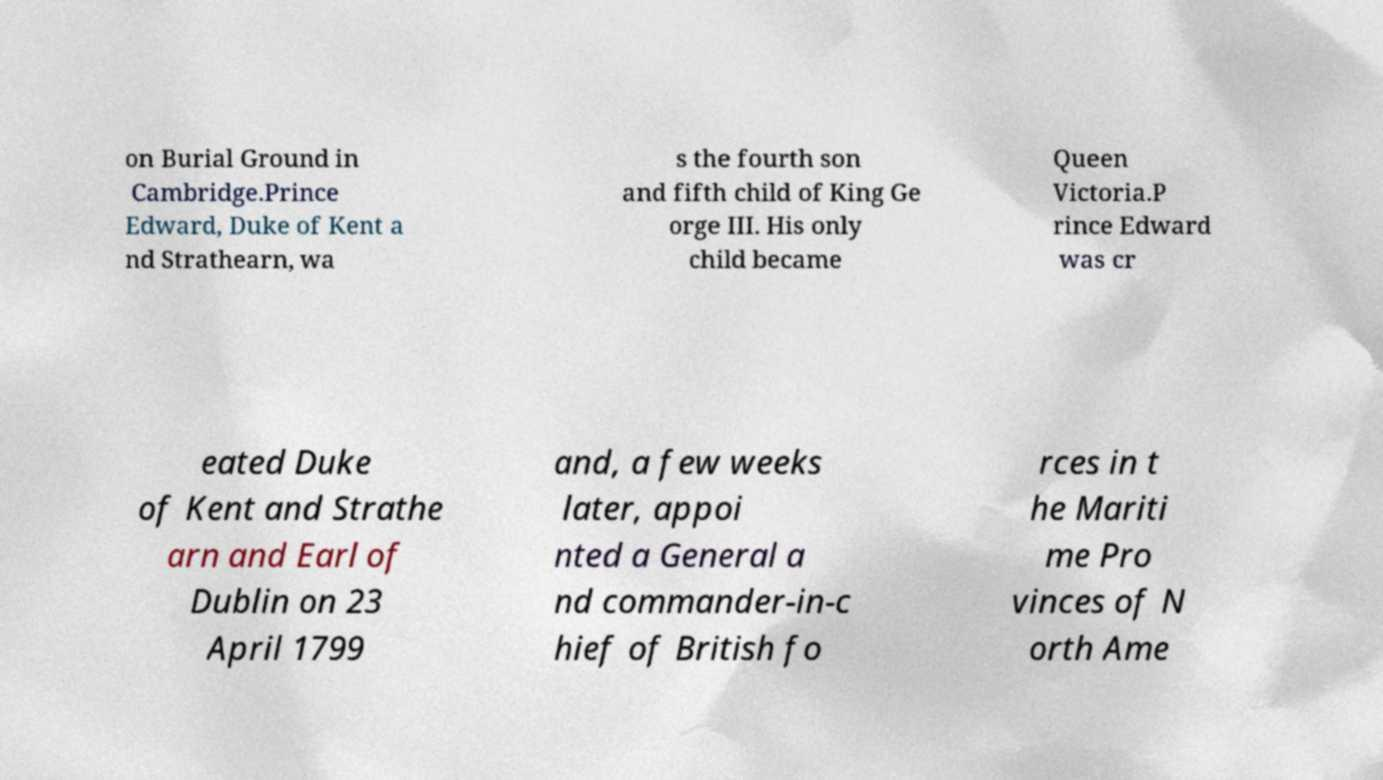Could you assist in decoding the text presented in this image and type it out clearly? on Burial Ground in Cambridge.Prince Edward, Duke of Kent a nd Strathearn, wa s the fourth son and fifth child of King Ge orge III. His only child became Queen Victoria.P rince Edward was cr eated Duke of Kent and Strathe arn and Earl of Dublin on 23 April 1799 and, a few weeks later, appoi nted a General a nd commander-in-c hief of British fo rces in t he Mariti me Pro vinces of N orth Ame 